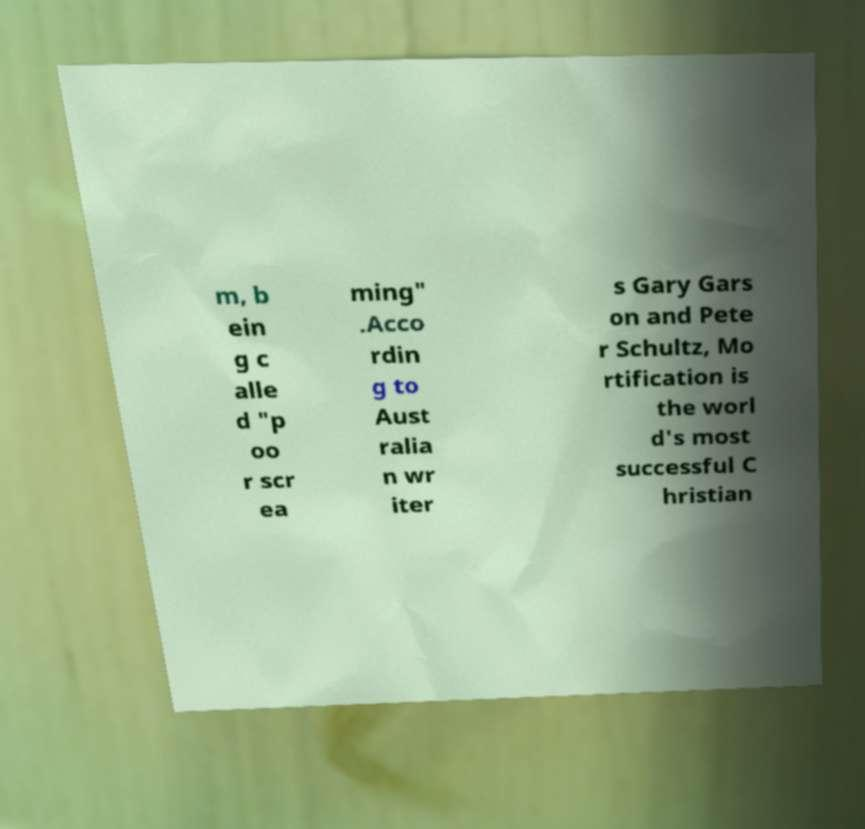I need the written content from this picture converted into text. Can you do that? m, b ein g c alle d "p oo r scr ea ming" .Acco rdin g to Aust ralia n wr iter s Gary Gars on and Pete r Schultz, Mo rtification is the worl d's most successful C hristian 